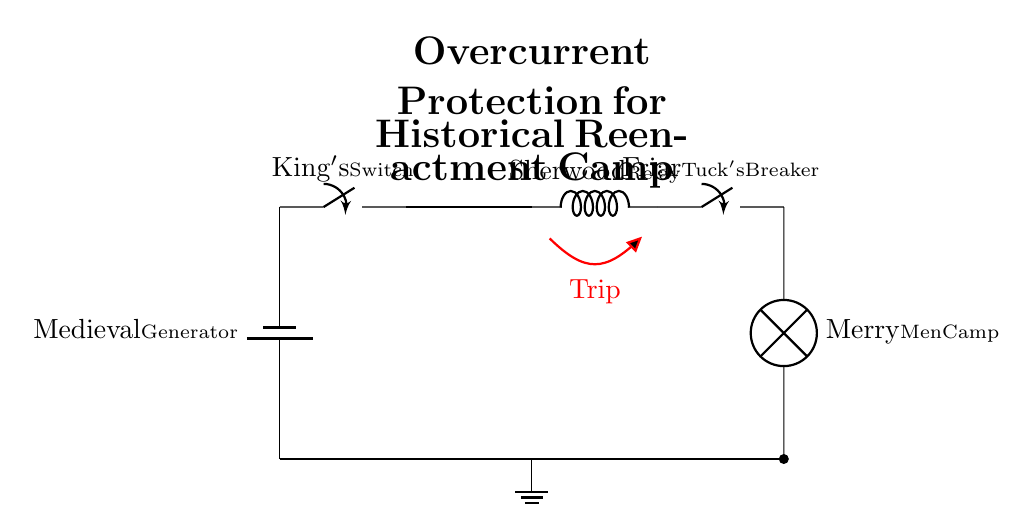What is the main power source in this circuit? The main power source is a battery labeled "Medieval Generator," which provides the necessary electrical energy for the circuit.
Answer: Medieval Generator What component represents the overcurrent protection in this circuit? The overcurrent protection is represented by the "Sherwood Relay," which monitors the current and triggers the trip action in case of overcurrent conditions.
Answer: Sherwood Relay How many circuit breakers are present in the diagram? There are two circuit breakers shown in the circuit diagram: the "King's Switch" and "Friar Tuck's Breaker."
Answer: Two What is the load connected at the end of the circuit? The load connected at the end of the circuit is a lamp labeled "Merry Men Camp," which indicates the point where electrical energy is utilized in the reenactment camp.
Answer: Merry Men Camp What happens when the overcurrent condition is detected? When overcurrent is detected, the "Trip" action is activated, which opens the circuit, preventing further current flow and protecting the devices involved.
Answer: Opens the circuit Where is the ground connection located in the circuit? The ground connection is located at the bottom of the circuit, connecting the main circuit to the ground symbol to ensure safety and stability in case of faults.
Answer: Bottom of the circuit 